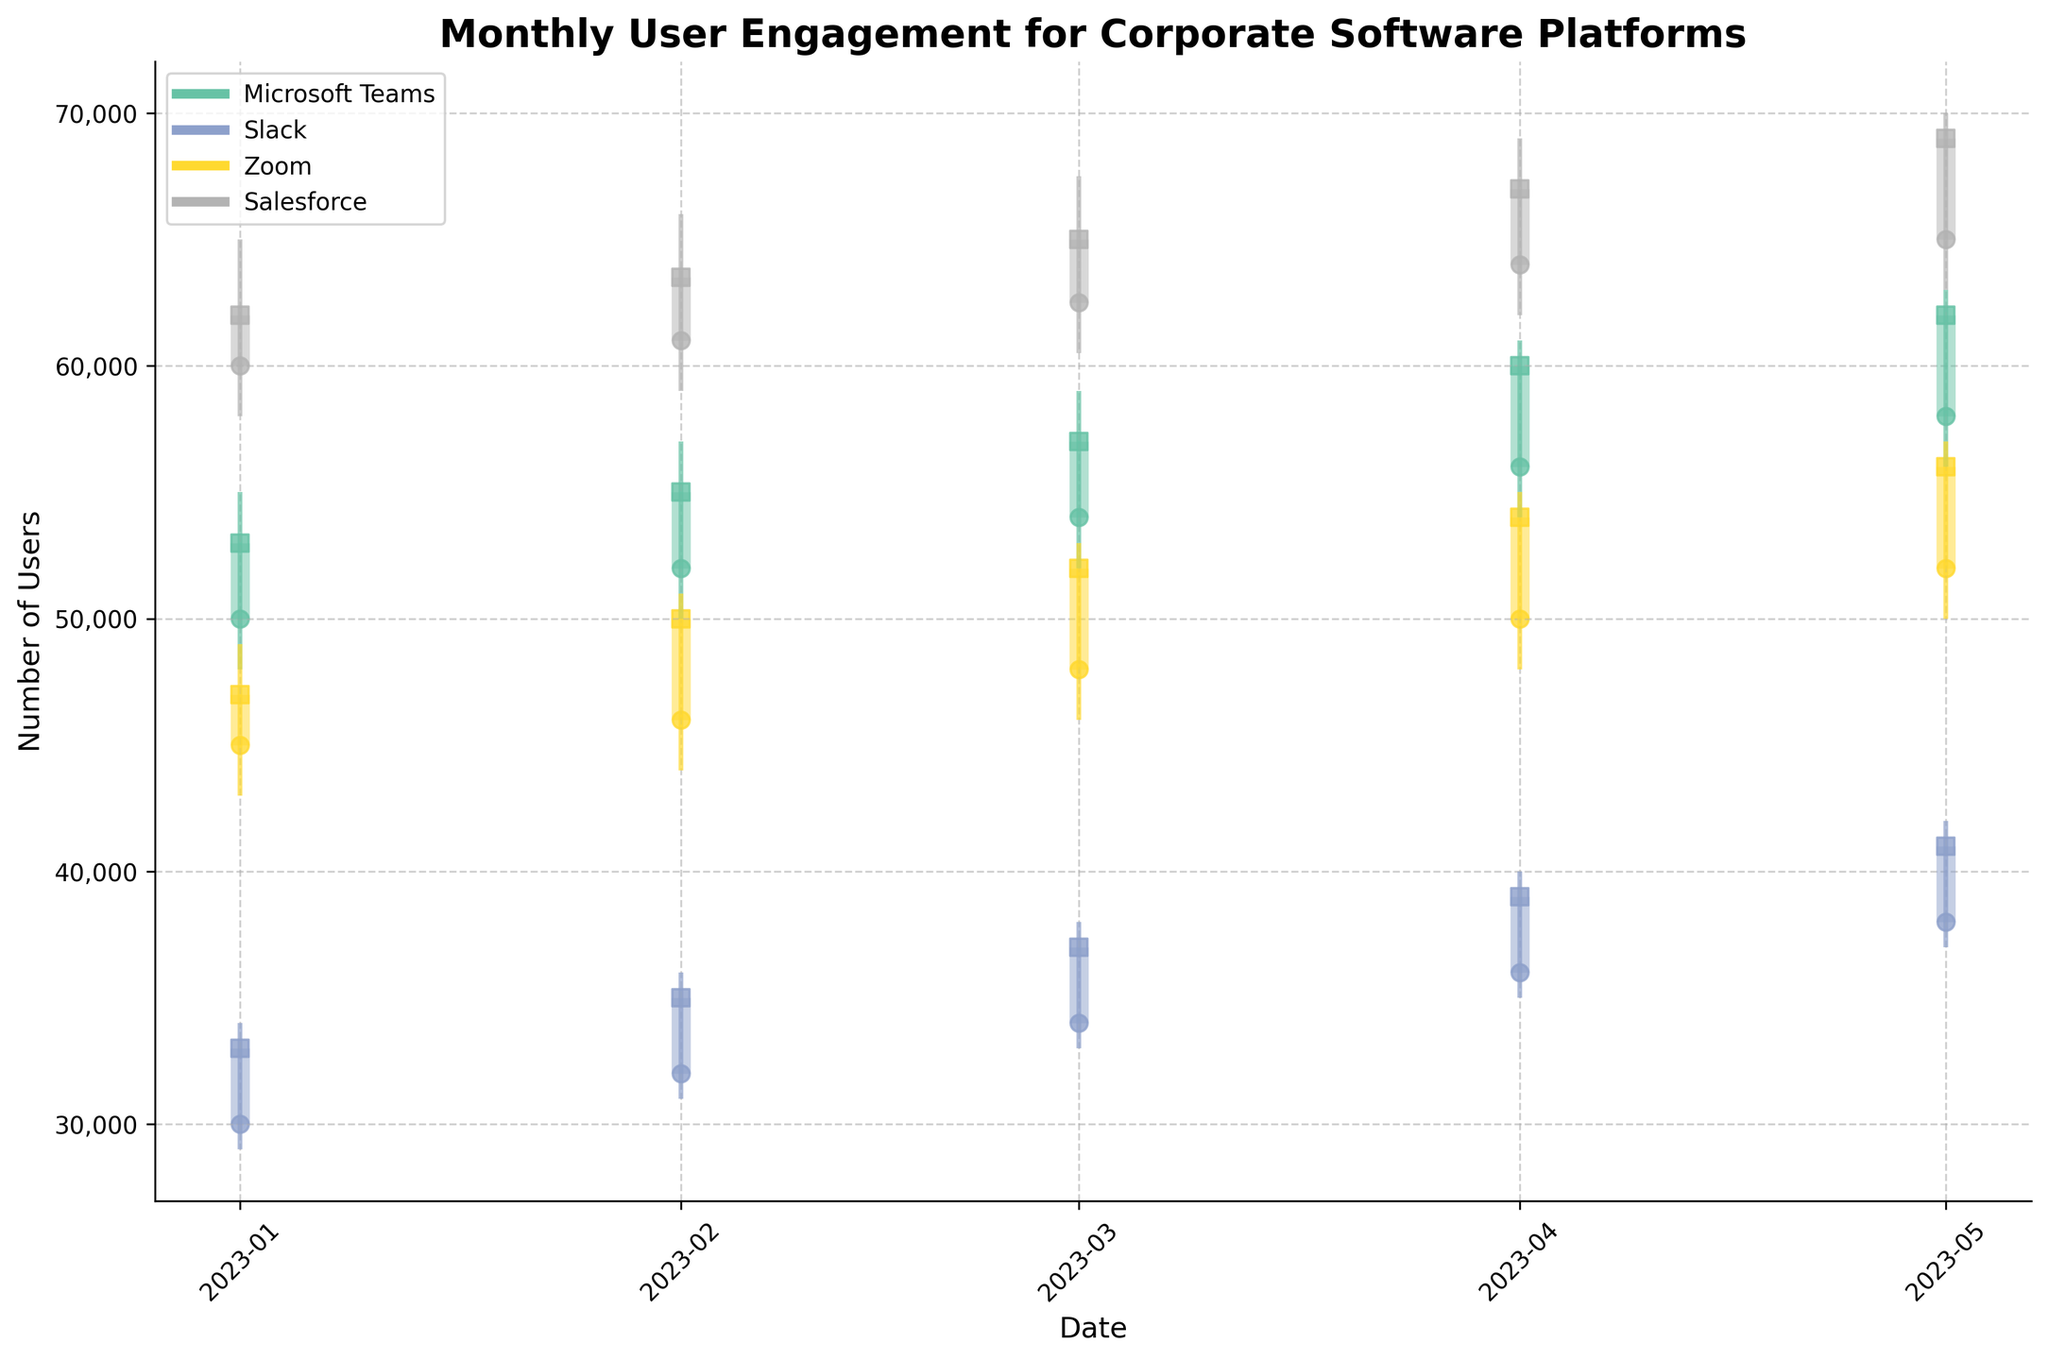What is the title of the figure? The title of the figure is prominently displayed at the top and reads "Monthly User Engagement for Corporate Software Platforms".
Answer: Monthly User Engagement for Corporate Software Platforms How many different corporate software platforms are shown in the figure? Each platform has its own color-coded data, visualized with candlestick markers, and there are four unique colors representing four platforms.
Answer: 4 Which software platform had the highest user engagement in January 2023? By looking at the user engagement data points for January 2023, Salesforce has the highest close value among all platforms.
Answer: Salesforce What was the user engagement range for Slack in April 2023? The range is determined by the difference between the high and low values. For Slack in April 2023, the high was 40,000 and the low was 35,000. Therefore, the user engagement range is 40,000 - 35,000.
Answer: 5,000 Compare the closing values of Microsoft Teams and Zoom in March 2023. Which one had a higher engagement? For March 2023, the closing value of Microsoft Teams was 57,000 users and for Zoom, it was 52,000 users. Therefore, Microsoft Teams had a higher engagement.
Answer: Microsoft Teams Which month did Salesforce reach its highest user engagement and what was the closing value? By examining the figure, Salesforce reached its highest user engagement in May 2023 with a closing value of 69,000 users.
Answer: May 2023, 69,000 Calculate the average closing value for Microsoft Teams from January to May 2023. The closing values for Microsoft Teams each month are: Jan - 53,000, Feb - 55,000, Mar - 57,000, Apr - 60,000, May - 62,000. Summing these values gives 287,000. The average is 287,000 / 5.
Answer: 57,400 Which platform showed the most consistent user engagement growth from January to May 2023? By analyzing the slopes of closing value lines for each platform, Microsoft Teams shows a steady increase without any dips, indicating the most consistent growth.
Answer: Microsoft Teams Is there a month where Slack's closing user engagement is higher than Zoom's? Which month is that? Observing the closing values of Slack and Zoom, in no month from January to May 2023 does Slack's closing value surpass Zoom's.
Answer: None How did Zoom's user engagement change from February to April 2023? From February's close of 50,000 to March's close of 52,000 and finally April's close of 54,000, Zoom’s user engagement shows a consistent month-on-month increase.
Answer: It increased 